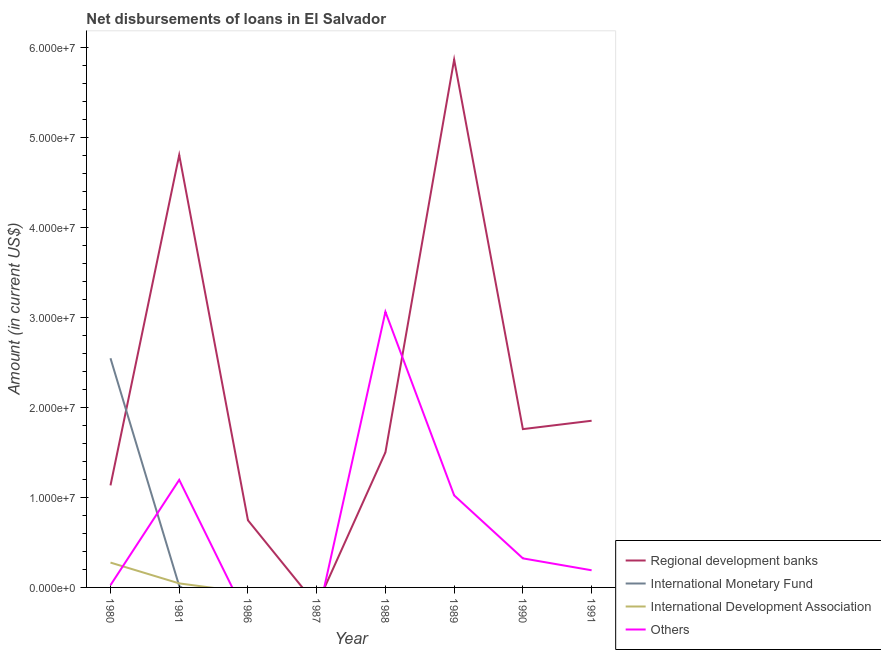How many different coloured lines are there?
Provide a short and direct response. 4. What is the amount of loan disimbursed by international monetary fund in 1991?
Provide a short and direct response. 0. Across all years, what is the maximum amount of loan disimbursed by international development association?
Offer a very short reply. 2.76e+06. Across all years, what is the minimum amount of loan disimbursed by international monetary fund?
Ensure brevity in your answer.  0. In which year was the amount of loan disimbursed by other organisations maximum?
Your answer should be very brief. 1988. What is the total amount of loan disimbursed by international development association in the graph?
Provide a succinct answer. 3.21e+06. What is the difference between the amount of loan disimbursed by other organisations in 1989 and that in 1991?
Offer a very short reply. 8.32e+06. What is the difference between the amount of loan disimbursed by regional development banks in 1989 and the amount of loan disimbursed by international monetary fund in 1988?
Your answer should be compact. 5.87e+07. What is the average amount of loan disimbursed by regional development banks per year?
Your response must be concise. 2.21e+07. In the year 1980, what is the difference between the amount of loan disimbursed by international development association and amount of loan disimbursed by regional development banks?
Keep it short and to the point. -8.58e+06. What is the ratio of the amount of loan disimbursed by other organisations in 1980 to that in 1988?
Offer a terse response. 0.01. Is the amount of loan disimbursed by other organisations in 1981 less than that in 1991?
Offer a terse response. No. What is the difference between the highest and the second highest amount of loan disimbursed by other organisations?
Your answer should be compact. 1.87e+07. What is the difference between the highest and the lowest amount of loan disimbursed by other organisations?
Provide a succinct answer. 3.06e+07. In how many years, is the amount of loan disimbursed by international monetary fund greater than the average amount of loan disimbursed by international monetary fund taken over all years?
Your answer should be very brief. 1. Is the sum of the amount of loan disimbursed by other organisations in 1980 and 1988 greater than the maximum amount of loan disimbursed by international monetary fund across all years?
Provide a short and direct response. Yes. Is it the case that in every year, the sum of the amount of loan disimbursed by regional development banks and amount of loan disimbursed by international monetary fund is greater than the amount of loan disimbursed by international development association?
Ensure brevity in your answer.  No. Is the amount of loan disimbursed by other organisations strictly greater than the amount of loan disimbursed by regional development banks over the years?
Your response must be concise. No. How many lines are there?
Ensure brevity in your answer.  4. What is the difference between two consecutive major ticks on the Y-axis?
Make the answer very short. 1.00e+07. Are the values on the major ticks of Y-axis written in scientific E-notation?
Make the answer very short. Yes. How many legend labels are there?
Give a very brief answer. 4. What is the title of the graph?
Your answer should be very brief. Net disbursements of loans in El Salvador. Does "Norway" appear as one of the legend labels in the graph?
Offer a very short reply. No. What is the label or title of the X-axis?
Ensure brevity in your answer.  Year. What is the label or title of the Y-axis?
Keep it short and to the point. Amount (in current US$). What is the Amount (in current US$) of Regional development banks in 1980?
Your answer should be compact. 1.13e+07. What is the Amount (in current US$) of International Monetary Fund in 1980?
Give a very brief answer. 2.55e+07. What is the Amount (in current US$) in International Development Association in 1980?
Ensure brevity in your answer.  2.76e+06. What is the Amount (in current US$) in Others in 1980?
Give a very brief answer. 2.52e+05. What is the Amount (in current US$) of Regional development banks in 1981?
Provide a short and direct response. 4.80e+07. What is the Amount (in current US$) of International Monetary Fund in 1981?
Ensure brevity in your answer.  1.56e+05. What is the Amount (in current US$) in International Development Association in 1981?
Your answer should be very brief. 4.47e+05. What is the Amount (in current US$) in Others in 1981?
Your answer should be very brief. 1.20e+07. What is the Amount (in current US$) in Regional development banks in 1986?
Offer a terse response. 7.46e+06. What is the Amount (in current US$) in International Monetary Fund in 1986?
Make the answer very short. 0. What is the Amount (in current US$) of International Development Association in 1986?
Give a very brief answer. 0. What is the Amount (in current US$) in Regional development banks in 1987?
Ensure brevity in your answer.  0. What is the Amount (in current US$) in International Development Association in 1987?
Provide a short and direct response. 0. What is the Amount (in current US$) of Regional development banks in 1988?
Give a very brief answer. 1.50e+07. What is the Amount (in current US$) of International Monetary Fund in 1988?
Ensure brevity in your answer.  0. What is the Amount (in current US$) in Others in 1988?
Your answer should be compact. 3.06e+07. What is the Amount (in current US$) in Regional development banks in 1989?
Your answer should be very brief. 5.87e+07. What is the Amount (in current US$) in International Monetary Fund in 1989?
Your answer should be very brief. 0. What is the Amount (in current US$) of International Development Association in 1989?
Make the answer very short. 0. What is the Amount (in current US$) in Others in 1989?
Give a very brief answer. 1.02e+07. What is the Amount (in current US$) of Regional development banks in 1990?
Your response must be concise. 1.76e+07. What is the Amount (in current US$) in Others in 1990?
Make the answer very short. 3.23e+06. What is the Amount (in current US$) of Regional development banks in 1991?
Your answer should be compact. 1.85e+07. What is the Amount (in current US$) of International Monetary Fund in 1991?
Ensure brevity in your answer.  0. What is the Amount (in current US$) in International Development Association in 1991?
Keep it short and to the point. 0. What is the Amount (in current US$) in Others in 1991?
Offer a very short reply. 1.90e+06. Across all years, what is the maximum Amount (in current US$) of Regional development banks?
Offer a very short reply. 5.87e+07. Across all years, what is the maximum Amount (in current US$) of International Monetary Fund?
Offer a terse response. 2.55e+07. Across all years, what is the maximum Amount (in current US$) in International Development Association?
Your answer should be compact. 2.76e+06. Across all years, what is the maximum Amount (in current US$) in Others?
Your answer should be compact. 3.06e+07. Across all years, what is the minimum Amount (in current US$) in Regional development banks?
Your response must be concise. 0. Across all years, what is the minimum Amount (in current US$) of Others?
Offer a very short reply. 0. What is the total Amount (in current US$) of Regional development banks in the graph?
Ensure brevity in your answer.  1.77e+08. What is the total Amount (in current US$) in International Monetary Fund in the graph?
Provide a succinct answer. 2.56e+07. What is the total Amount (in current US$) of International Development Association in the graph?
Offer a very short reply. 3.21e+06. What is the total Amount (in current US$) of Others in the graph?
Provide a short and direct response. 5.82e+07. What is the difference between the Amount (in current US$) of Regional development banks in 1980 and that in 1981?
Make the answer very short. -3.67e+07. What is the difference between the Amount (in current US$) of International Monetary Fund in 1980 and that in 1981?
Offer a terse response. 2.53e+07. What is the difference between the Amount (in current US$) in International Development Association in 1980 and that in 1981?
Provide a succinct answer. 2.31e+06. What is the difference between the Amount (in current US$) of Others in 1980 and that in 1981?
Provide a succinct answer. -1.17e+07. What is the difference between the Amount (in current US$) of Regional development banks in 1980 and that in 1986?
Offer a terse response. 3.88e+06. What is the difference between the Amount (in current US$) in Regional development banks in 1980 and that in 1988?
Ensure brevity in your answer.  -3.67e+06. What is the difference between the Amount (in current US$) of Others in 1980 and that in 1988?
Make the answer very short. -3.04e+07. What is the difference between the Amount (in current US$) of Regional development banks in 1980 and that in 1989?
Your answer should be compact. -4.73e+07. What is the difference between the Amount (in current US$) in Others in 1980 and that in 1989?
Make the answer very short. -9.98e+06. What is the difference between the Amount (in current US$) of Regional development banks in 1980 and that in 1990?
Make the answer very short. -6.25e+06. What is the difference between the Amount (in current US$) of Others in 1980 and that in 1990?
Provide a succinct answer. -2.98e+06. What is the difference between the Amount (in current US$) of Regional development banks in 1980 and that in 1991?
Give a very brief answer. -7.18e+06. What is the difference between the Amount (in current US$) of Others in 1980 and that in 1991?
Give a very brief answer. -1.65e+06. What is the difference between the Amount (in current US$) in Regional development banks in 1981 and that in 1986?
Provide a succinct answer. 4.06e+07. What is the difference between the Amount (in current US$) in Regional development banks in 1981 and that in 1988?
Give a very brief answer. 3.30e+07. What is the difference between the Amount (in current US$) in Others in 1981 and that in 1988?
Ensure brevity in your answer.  -1.87e+07. What is the difference between the Amount (in current US$) of Regional development banks in 1981 and that in 1989?
Your answer should be compact. -1.06e+07. What is the difference between the Amount (in current US$) in Others in 1981 and that in 1989?
Ensure brevity in your answer.  1.72e+06. What is the difference between the Amount (in current US$) in Regional development banks in 1981 and that in 1990?
Your response must be concise. 3.05e+07. What is the difference between the Amount (in current US$) in Others in 1981 and that in 1990?
Provide a succinct answer. 8.72e+06. What is the difference between the Amount (in current US$) of Regional development banks in 1981 and that in 1991?
Give a very brief answer. 2.95e+07. What is the difference between the Amount (in current US$) of Others in 1981 and that in 1991?
Make the answer very short. 1.00e+07. What is the difference between the Amount (in current US$) of Regional development banks in 1986 and that in 1988?
Your answer should be very brief. -7.54e+06. What is the difference between the Amount (in current US$) in Regional development banks in 1986 and that in 1989?
Give a very brief answer. -5.12e+07. What is the difference between the Amount (in current US$) of Regional development banks in 1986 and that in 1990?
Provide a short and direct response. -1.01e+07. What is the difference between the Amount (in current US$) in Regional development banks in 1986 and that in 1991?
Your response must be concise. -1.11e+07. What is the difference between the Amount (in current US$) of Regional development banks in 1988 and that in 1989?
Offer a very short reply. -4.36e+07. What is the difference between the Amount (in current US$) of Others in 1988 and that in 1989?
Give a very brief answer. 2.04e+07. What is the difference between the Amount (in current US$) of Regional development banks in 1988 and that in 1990?
Provide a succinct answer. -2.59e+06. What is the difference between the Amount (in current US$) in Others in 1988 and that in 1990?
Your answer should be compact. 2.74e+07. What is the difference between the Amount (in current US$) of Regional development banks in 1988 and that in 1991?
Provide a succinct answer. -3.52e+06. What is the difference between the Amount (in current US$) of Others in 1988 and that in 1991?
Offer a very short reply. 2.87e+07. What is the difference between the Amount (in current US$) in Regional development banks in 1989 and that in 1990?
Offer a terse response. 4.11e+07. What is the difference between the Amount (in current US$) of Others in 1989 and that in 1990?
Provide a succinct answer. 7.00e+06. What is the difference between the Amount (in current US$) in Regional development banks in 1989 and that in 1991?
Your answer should be very brief. 4.01e+07. What is the difference between the Amount (in current US$) of Others in 1989 and that in 1991?
Provide a succinct answer. 8.32e+06. What is the difference between the Amount (in current US$) in Regional development banks in 1990 and that in 1991?
Provide a short and direct response. -9.30e+05. What is the difference between the Amount (in current US$) of Others in 1990 and that in 1991?
Provide a succinct answer. 1.32e+06. What is the difference between the Amount (in current US$) of Regional development banks in 1980 and the Amount (in current US$) of International Monetary Fund in 1981?
Make the answer very short. 1.12e+07. What is the difference between the Amount (in current US$) of Regional development banks in 1980 and the Amount (in current US$) of International Development Association in 1981?
Ensure brevity in your answer.  1.09e+07. What is the difference between the Amount (in current US$) in Regional development banks in 1980 and the Amount (in current US$) in Others in 1981?
Offer a very short reply. -6.13e+05. What is the difference between the Amount (in current US$) in International Monetary Fund in 1980 and the Amount (in current US$) in International Development Association in 1981?
Your answer should be compact. 2.50e+07. What is the difference between the Amount (in current US$) in International Monetary Fund in 1980 and the Amount (in current US$) in Others in 1981?
Provide a succinct answer. 1.35e+07. What is the difference between the Amount (in current US$) in International Development Association in 1980 and the Amount (in current US$) in Others in 1981?
Your answer should be very brief. -9.19e+06. What is the difference between the Amount (in current US$) in Regional development banks in 1980 and the Amount (in current US$) in Others in 1988?
Keep it short and to the point. -1.93e+07. What is the difference between the Amount (in current US$) in International Monetary Fund in 1980 and the Amount (in current US$) in Others in 1988?
Offer a terse response. -5.16e+06. What is the difference between the Amount (in current US$) of International Development Association in 1980 and the Amount (in current US$) of Others in 1988?
Give a very brief answer. -2.79e+07. What is the difference between the Amount (in current US$) in Regional development banks in 1980 and the Amount (in current US$) in Others in 1989?
Keep it short and to the point. 1.11e+06. What is the difference between the Amount (in current US$) of International Monetary Fund in 1980 and the Amount (in current US$) of Others in 1989?
Your answer should be compact. 1.52e+07. What is the difference between the Amount (in current US$) in International Development Association in 1980 and the Amount (in current US$) in Others in 1989?
Make the answer very short. -7.47e+06. What is the difference between the Amount (in current US$) in Regional development banks in 1980 and the Amount (in current US$) in Others in 1990?
Your answer should be compact. 8.11e+06. What is the difference between the Amount (in current US$) in International Monetary Fund in 1980 and the Amount (in current US$) in Others in 1990?
Make the answer very short. 2.22e+07. What is the difference between the Amount (in current US$) in International Development Association in 1980 and the Amount (in current US$) in Others in 1990?
Your response must be concise. -4.69e+05. What is the difference between the Amount (in current US$) of Regional development banks in 1980 and the Amount (in current US$) of Others in 1991?
Your answer should be very brief. 9.43e+06. What is the difference between the Amount (in current US$) of International Monetary Fund in 1980 and the Amount (in current US$) of Others in 1991?
Ensure brevity in your answer.  2.36e+07. What is the difference between the Amount (in current US$) of International Development Association in 1980 and the Amount (in current US$) of Others in 1991?
Offer a terse response. 8.55e+05. What is the difference between the Amount (in current US$) of Regional development banks in 1981 and the Amount (in current US$) of Others in 1988?
Offer a very short reply. 1.74e+07. What is the difference between the Amount (in current US$) of International Monetary Fund in 1981 and the Amount (in current US$) of Others in 1988?
Provide a short and direct response. -3.05e+07. What is the difference between the Amount (in current US$) in International Development Association in 1981 and the Amount (in current US$) in Others in 1988?
Keep it short and to the point. -3.02e+07. What is the difference between the Amount (in current US$) of Regional development banks in 1981 and the Amount (in current US$) of Others in 1989?
Give a very brief answer. 3.78e+07. What is the difference between the Amount (in current US$) of International Monetary Fund in 1981 and the Amount (in current US$) of Others in 1989?
Provide a short and direct response. -1.01e+07. What is the difference between the Amount (in current US$) in International Development Association in 1981 and the Amount (in current US$) in Others in 1989?
Keep it short and to the point. -9.78e+06. What is the difference between the Amount (in current US$) in Regional development banks in 1981 and the Amount (in current US$) in Others in 1990?
Make the answer very short. 4.48e+07. What is the difference between the Amount (in current US$) in International Monetary Fund in 1981 and the Amount (in current US$) in Others in 1990?
Your answer should be very brief. -3.07e+06. What is the difference between the Amount (in current US$) of International Development Association in 1981 and the Amount (in current US$) of Others in 1990?
Your answer should be compact. -2.78e+06. What is the difference between the Amount (in current US$) of Regional development banks in 1981 and the Amount (in current US$) of Others in 1991?
Your answer should be compact. 4.61e+07. What is the difference between the Amount (in current US$) in International Monetary Fund in 1981 and the Amount (in current US$) in Others in 1991?
Ensure brevity in your answer.  -1.75e+06. What is the difference between the Amount (in current US$) of International Development Association in 1981 and the Amount (in current US$) of Others in 1991?
Your answer should be very brief. -1.46e+06. What is the difference between the Amount (in current US$) in Regional development banks in 1986 and the Amount (in current US$) in Others in 1988?
Offer a very short reply. -2.32e+07. What is the difference between the Amount (in current US$) of Regional development banks in 1986 and the Amount (in current US$) of Others in 1989?
Offer a terse response. -2.77e+06. What is the difference between the Amount (in current US$) in Regional development banks in 1986 and the Amount (in current US$) in Others in 1990?
Make the answer very short. 4.23e+06. What is the difference between the Amount (in current US$) of Regional development banks in 1986 and the Amount (in current US$) of Others in 1991?
Your response must be concise. 5.56e+06. What is the difference between the Amount (in current US$) of Regional development banks in 1988 and the Amount (in current US$) of Others in 1989?
Keep it short and to the point. 4.78e+06. What is the difference between the Amount (in current US$) of Regional development banks in 1988 and the Amount (in current US$) of Others in 1990?
Your answer should be very brief. 1.18e+07. What is the difference between the Amount (in current US$) in Regional development banks in 1988 and the Amount (in current US$) in Others in 1991?
Your answer should be very brief. 1.31e+07. What is the difference between the Amount (in current US$) in Regional development banks in 1989 and the Amount (in current US$) in Others in 1990?
Keep it short and to the point. 5.54e+07. What is the difference between the Amount (in current US$) of Regional development banks in 1989 and the Amount (in current US$) of Others in 1991?
Offer a very short reply. 5.67e+07. What is the difference between the Amount (in current US$) of Regional development banks in 1990 and the Amount (in current US$) of Others in 1991?
Give a very brief answer. 1.57e+07. What is the average Amount (in current US$) of Regional development banks per year?
Your answer should be compact. 2.21e+07. What is the average Amount (in current US$) of International Monetary Fund per year?
Provide a succinct answer. 3.20e+06. What is the average Amount (in current US$) of International Development Association per year?
Offer a very short reply. 4.01e+05. What is the average Amount (in current US$) of Others per year?
Provide a short and direct response. 7.27e+06. In the year 1980, what is the difference between the Amount (in current US$) in Regional development banks and Amount (in current US$) in International Monetary Fund?
Offer a terse response. -1.41e+07. In the year 1980, what is the difference between the Amount (in current US$) in Regional development banks and Amount (in current US$) in International Development Association?
Your response must be concise. 8.58e+06. In the year 1980, what is the difference between the Amount (in current US$) of Regional development banks and Amount (in current US$) of Others?
Give a very brief answer. 1.11e+07. In the year 1980, what is the difference between the Amount (in current US$) in International Monetary Fund and Amount (in current US$) in International Development Association?
Your response must be concise. 2.27e+07. In the year 1980, what is the difference between the Amount (in current US$) of International Monetary Fund and Amount (in current US$) of Others?
Keep it short and to the point. 2.52e+07. In the year 1980, what is the difference between the Amount (in current US$) of International Development Association and Amount (in current US$) of Others?
Make the answer very short. 2.51e+06. In the year 1981, what is the difference between the Amount (in current US$) of Regional development banks and Amount (in current US$) of International Monetary Fund?
Your response must be concise. 4.79e+07. In the year 1981, what is the difference between the Amount (in current US$) in Regional development banks and Amount (in current US$) in International Development Association?
Your answer should be compact. 4.76e+07. In the year 1981, what is the difference between the Amount (in current US$) of Regional development banks and Amount (in current US$) of Others?
Offer a very short reply. 3.61e+07. In the year 1981, what is the difference between the Amount (in current US$) in International Monetary Fund and Amount (in current US$) in International Development Association?
Offer a terse response. -2.91e+05. In the year 1981, what is the difference between the Amount (in current US$) of International Monetary Fund and Amount (in current US$) of Others?
Provide a short and direct response. -1.18e+07. In the year 1981, what is the difference between the Amount (in current US$) of International Development Association and Amount (in current US$) of Others?
Give a very brief answer. -1.15e+07. In the year 1988, what is the difference between the Amount (in current US$) in Regional development banks and Amount (in current US$) in Others?
Keep it short and to the point. -1.56e+07. In the year 1989, what is the difference between the Amount (in current US$) in Regional development banks and Amount (in current US$) in Others?
Make the answer very short. 4.84e+07. In the year 1990, what is the difference between the Amount (in current US$) of Regional development banks and Amount (in current US$) of Others?
Ensure brevity in your answer.  1.44e+07. In the year 1991, what is the difference between the Amount (in current US$) in Regional development banks and Amount (in current US$) in Others?
Offer a terse response. 1.66e+07. What is the ratio of the Amount (in current US$) of Regional development banks in 1980 to that in 1981?
Your response must be concise. 0.24. What is the ratio of the Amount (in current US$) of International Monetary Fund in 1980 to that in 1981?
Provide a short and direct response. 163.24. What is the ratio of the Amount (in current US$) in International Development Association in 1980 to that in 1981?
Offer a terse response. 6.17. What is the ratio of the Amount (in current US$) in Others in 1980 to that in 1981?
Keep it short and to the point. 0.02. What is the ratio of the Amount (in current US$) in Regional development banks in 1980 to that in 1986?
Make the answer very short. 1.52. What is the ratio of the Amount (in current US$) in Regional development banks in 1980 to that in 1988?
Make the answer very short. 0.76. What is the ratio of the Amount (in current US$) of Others in 1980 to that in 1988?
Offer a terse response. 0.01. What is the ratio of the Amount (in current US$) in Regional development banks in 1980 to that in 1989?
Give a very brief answer. 0.19. What is the ratio of the Amount (in current US$) of Others in 1980 to that in 1989?
Provide a succinct answer. 0.02. What is the ratio of the Amount (in current US$) in Regional development banks in 1980 to that in 1990?
Offer a terse response. 0.64. What is the ratio of the Amount (in current US$) of Others in 1980 to that in 1990?
Ensure brevity in your answer.  0.08. What is the ratio of the Amount (in current US$) of Regional development banks in 1980 to that in 1991?
Give a very brief answer. 0.61. What is the ratio of the Amount (in current US$) in Others in 1980 to that in 1991?
Make the answer very short. 0.13. What is the ratio of the Amount (in current US$) of Regional development banks in 1981 to that in 1986?
Make the answer very short. 6.44. What is the ratio of the Amount (in current US$) in Regional development banks in 1981 to that in 1988?
Make the answer very short. 3.2. What is the ratio of the Amount (in current US$) in Others in 1981 to that in 1988?
Give a very brief answer. 0.39. What is the ratio of the Amount (in current US$) of Regional development banks in 1981 to that in 1989?
Offer a very short reply. 0.82. What is the ratio of the Amount (in current US$) in Others in 1981 to that in 1989?
Your answer should be compact. 1.17. What is the ratio of the Amount (in current US$) in Regional development banks in 1981 to that in 1990?
Provide a succinct answer. 2.73. What is the ratio of the Amount (in current US$) of Others in 1981 to that in 1990?
Provide a short and direct response. 3.7. What is the ratio of the Amount (in current US$) of Regional development banks in 1981 to that in 1991?
Keep it short and to the point. 2.59. What is the ratio of the Amount (in current US$) of Others in 1981 to that in 1991?
Ensure brevity in your answer.  6.27. What is the ratio of the Amount (in current US$) in Regional development banks in 1986 to that in 1988?
Your answer should be very brief. 0.5. What is the ratio of the Amount (in current US$) of Regional development banks in 1986 to that in 1989?
Your answer should be compact. 0.13. What is the ratio of the Amount (in current US$) of Regional development banks in 1986 to that in 1990?
Make the answer very short. 0.42. What is the ratio of the Amount (in current US$) of Regional development banks in 1986 to that in 1991?
Ensure brevity in your answer.  0.4. What is the ratio of the Amount (in current US$) of Regional development banks in 1988 to that in 1989?
Your answer should be very brief. 0.26. What is the ratio of the Amount (in current US$) of Others in 1988 to that in 1989?
Your answer should be compact. 2.99. What is the ratio of the Amount (in current US$) of Regional development banks in 1988 to that in 1990?
Your answer should be compact. 0.85. What is the ratio of the Amount (in current US$) of Others in 1988 to that in 1990?
Your response must be concise. 9.48. What is the ratio of the Amount (in current US$) of Regional development banks in 1988 to that in 1991?
Your answer should be very brief. 0.81. What is the ratio of the Amount (in current US$) in Others in 1988 to that in 1991?
Provide a succinct answer. 16.08. What is the ratio of the Amount (in current US$) of Regional development banks in 1989 to that in 1990?
Provide a short and direct response. 3.33. What is the ratio of the Amount (in current US$) of Others in 1989 to that in 1990?
Your response must be concise. 3.17. What is the ratio of the Amount (in current US$) in Regional development banks in 1989 to that in 1991?
Make the answer very short. 3.17. What is the ratio of the Amount (in current US$) of Others in 1989 to that in 1991?
Offer a very short reply. 5.37. What is the ratio of the Amount (in current US$) of Regional development banks in 1990 to that in 1991?
Your response must be concise. 0.95. What is the ratio of the Amount (in current US$) in Others in 1990 to that in 1991?
Offer a terse response. 1.7. What is the difference between the highest and the second highest Amount (in current US$) in Regional development banks?
Your answer should be very brief. 1.06e+07. What is the difference between the highest and the second highest Amount (in current US$) of Others?
Offer a very short reply. 1.87e+07. What is the difference between the highest and the lowest Amount (in current US$) of Regional development banks?
Offer a terse response. 5.87e+07. What is the difference between the highest and the lowest Amount (in current US$) in International Monetary Fund?
Your answer should be very brief. 2.55e+07. What is the difference between the highest and the lowest Amount (in current US$) of International Development Association?
Your response must be concise. 2.76e+06. What is the difference between the highest and the lowest Amount (in current US$) in Others?
Your response must be concise. 3.06e+07. 